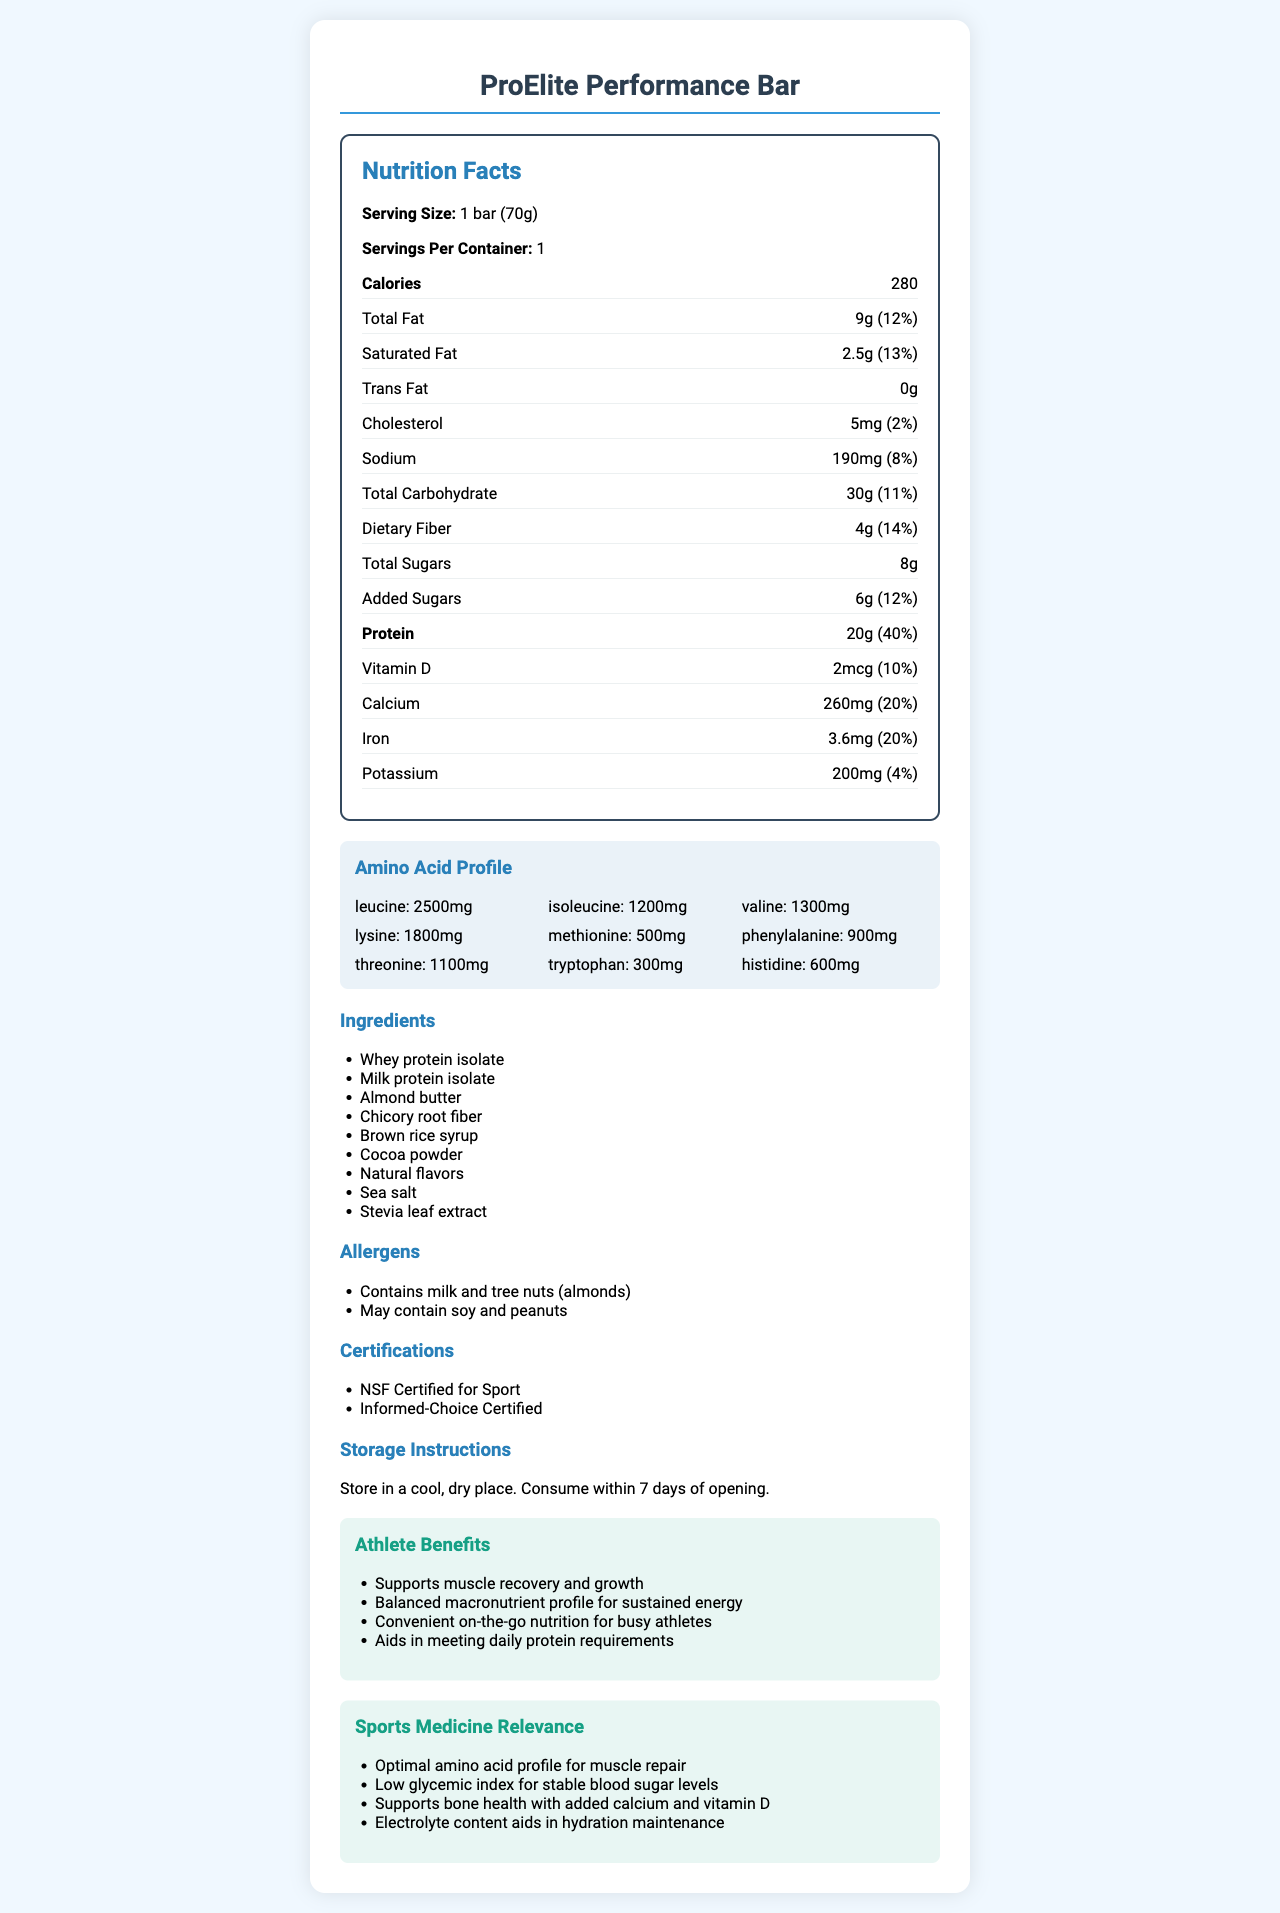what is the serving size of the ProElite Performance Bar? The serving size is explicitly mentioned at the top of the Nutrition Facts section as "1 bar (70g)".
Answer: 1 bar (70g) how many calories are in one serving? This is directly stated under the calorie section of the Nutrition Facts.
Answer: 280 what is the amount of protein per serving? The protein amount is clearly indicated under the nutrition items as "Protein: 20g".
Answer: 20g what are the primary allergens in the ProElite Performance Bar? This information is listed under the "Allergens" section of the document.
Answer: Contains milk and tree nuts (almonds) how should the ProElite Performance Bar be stored? The storage instructions are provided at the end of the document.
Answer: Store in a cool, dry place. Consume within 7 days of opening. how much sodium is in one serving? The sodium amount is found under the nutrition items section as "Sodium: 190mg".
Answer: 190mg what is the daily value percentage of dietary fiber? The dietary fiber daily value percentage is listed next to the amount in the nutrition items section.
Answer: 14% does the ProElite Performance Bar contain any trans fat? The document states "Trans Fat: 0g".
Answer: No which of the following amino acids has the highest amount in the ProElite Performance Bar?
A. Leucine
B. Isoleucine
C. Methionine
D. Valine Leucine has 2500mg, which is the highest among the listed amino acids.
Answer: A. Leucine which vitamin or mineral helps in supporting bone health, as mentioned in the sports medicine relevance section?
A. Vitamin D
B. Calcium
C. Potassium
D. Both A and B The sports medicine relevance mentions that both Vitamin D and Calcium support bone health.
Answer: D. Both A and B which certification does the ProElite Performance Bar NOT have?
A. NSF Certified for Sport
B. Informed-Choice Certified
C. FDA Approved The certifications listed are "NSF Certified for Sport" and "Informed-Choice Certified".
Answer: C. FDA Approved is the ProElite Performance Bar suitable for someone with a peanut allergy? The document states that the product "May contain soy and peanuts" under allergens.
Answer: No what are the athlete benefits of the ProElite Performance Bar? These benefits are listed under the "Athlete Benefits" section of the document.
Answer: Supports muscle recovery and growth, Balanced macronutrient profile for sustained energy, Convenient on-the-go nutrition for busy athletes, Aids in meeting daily protein requirements summarize the main idea of the ProElite Performance Bar's Nutrition Facts Label. This summary captures the essential information provided in the entire document, highlighting the primary nutrition facts, athlete benefits, certifications, and allergen information.
Answer: The ProElite Performance Bar is a protein-rich meal replacement that supports muscle recovery and growth, balanced with macronutrients for sustained energy. It contains essential amino acids, vital vitamins, and minerals. The bar is certified for sports and contains allergens like milk and almonds. It also provides a list of athlete benefits and storage instructions. what is the glycemic index of the ProElite Performance Bar? The document does not provide any information about the glycemic index of the bar.
Answer: Not enough information 